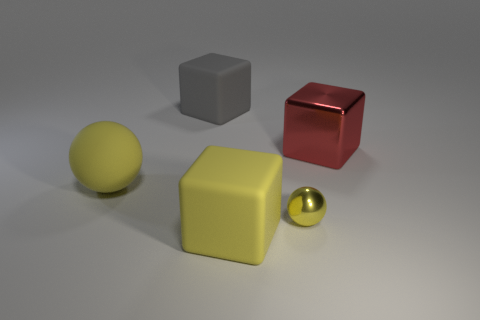Add 4 tiny spheres. How many objects exist? 9 Subtract all balls. How many objects are left? 3 Add 5 tiny things. How many tiny things exist? 6 Subtract 0 brown cubes. How many objects are left? 5 Subtract all spheres. Subtract all red things. How many objects are left? 2 Add 1 small metallic things. How many small metallic things are left? 2 